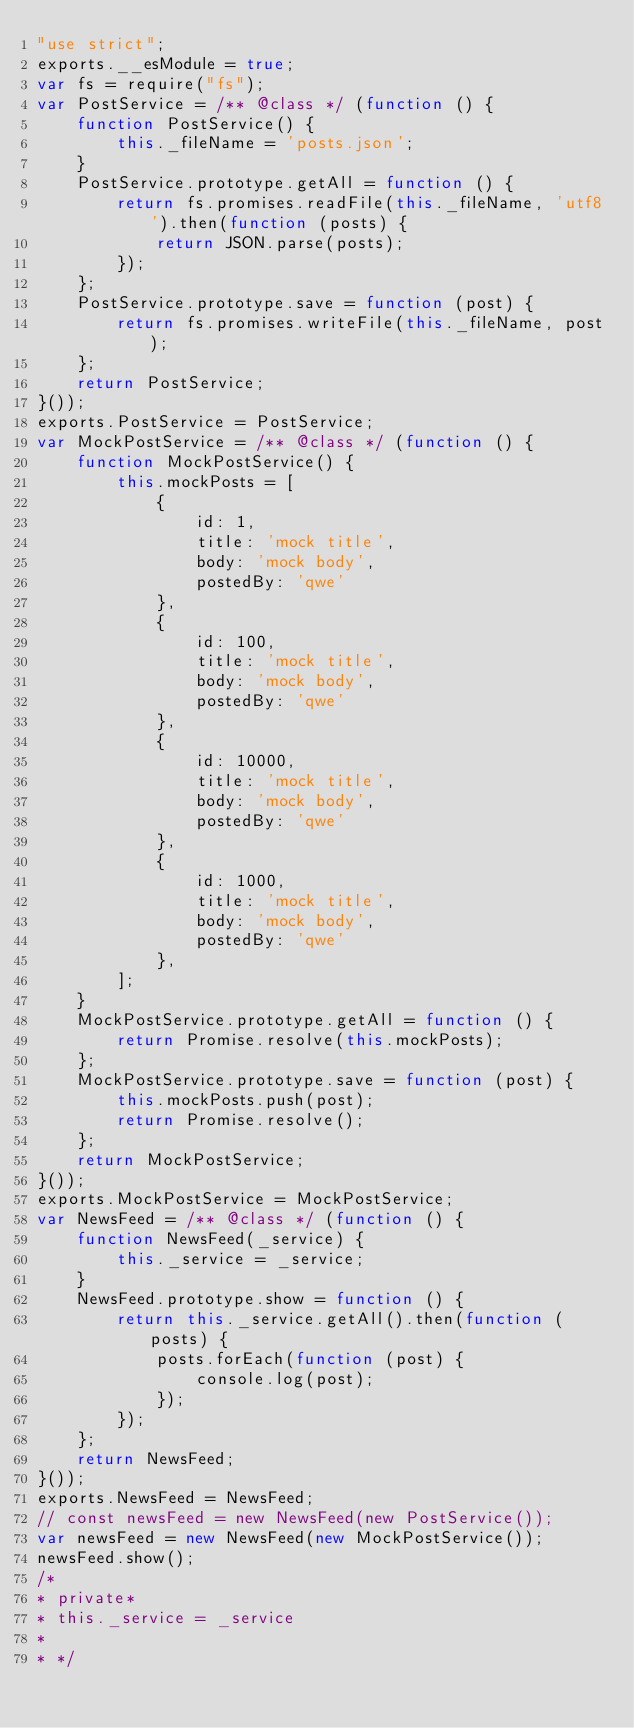<code> <loc_0><loc_0><loc_500><loc_500><_JavaScript_>"use strict";
exports.__esModule = true;
var fs = require("fs");
var PostService = /** @class */ (function () {
    function PostService() {
        this._fileName = 'posts.json';
    }
    PostService.prototype.getAll = function () {
        return fs.promises.readFile(this._fileName, 'utf8').then(function (posts) {
            return JSON.parse(posts);
        });
    };
    PostService.prototype.save = function (post) {
        return fs.promises.writeFile(this._fileName, post);
    };
    return PostService;
}());
exports.PostService = PostService;
var MockPostService = /** @class */ (function () {
    function MockPostService() {
        this.mockPosts = [
            {
                id: 1,
                title: 'mock title',
                body: 'mock body',
                postedBy: 'qwe'
            },
            {
                id: 100,
                title: 'mock title',
                body: 'mock body',
                postedBy: 'qwe'
            },
            {
                id: 10000,
                title: 'mock title',
                body: 'mock body',
                postedBy: 'qwe'
            },
            {
                id: 1000,
                title: 'mock title',
                body: 'mock body',
                postedBy: 'qwe'
            },
        ];
    }
    MockPostService.prototype.getAll = function () {
        return Promise.resolve(this.mockPosts);
    };
    MockPostService.prototype.save = function (post) {
        this.mockPosts.push(post);
        return Promise.resolve();
    };
    return MockPostService;
}());
exports.MockPostService = MockPostService;
var NewsFeed = /** @class */ (function () {
    function NewsFeed(_service) {
        this._service = _service;
    }
    NewsFeed.prototype.show = function () {
        return this._service.getAll().then(function (posts) {
            posts.forEach(function (post) {
                console.log(post);
            });
        });
    };
    return NewsFeed;
}());
exports.NewsFeed = NewsFeed;
// const newsFeed = new NewsFeed(new PostService());
var newsFeed = new NewsFeed(new MockPostService());
newsFeed.show();
/*
* private*
* this._service = _service
*
* */
</code> 